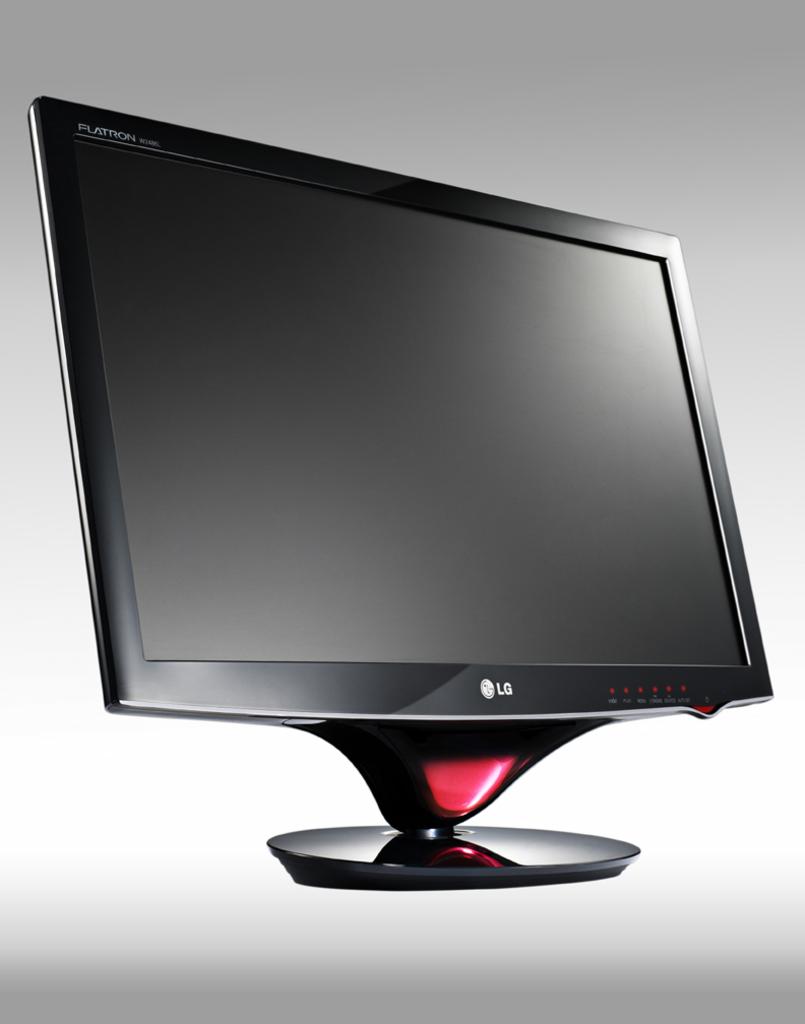What is the brand of this monitor?
Provide a succinct answer. Lg. What type of monitor is this listed in the top left corner?
Ensure brevity in your answer.  Lg. 